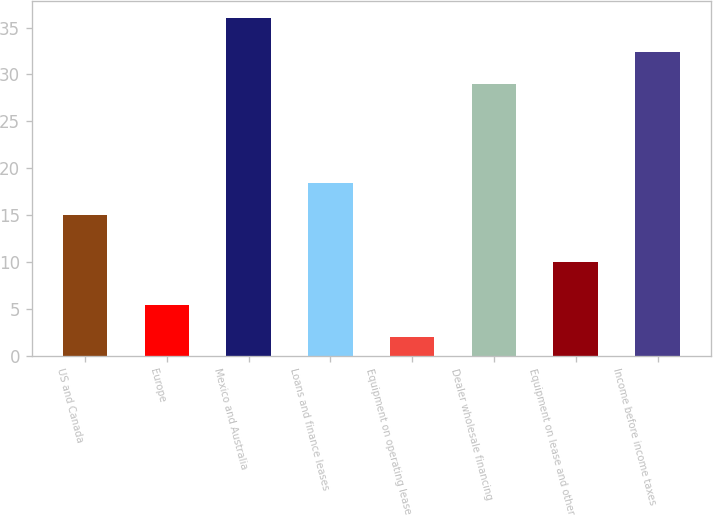<chart> <loc_0><loc_0><loc_500><loc_500><bar_chart><fcel>US and Canada<fcel>Europe<fcel>Mexico and Australia<fcel>Loans and finance leases<fcel>Equipment on operating lease<fcel>Dealer wholesale financing<fcel>Equipment on lease and other<fcel>Income before income taxes<nl><fcel>15<fcel>5.4<fcel>36<fcel>18.4<fcel>2<fcel>29<fcel>10<fcel>32.4<nl></chart> 